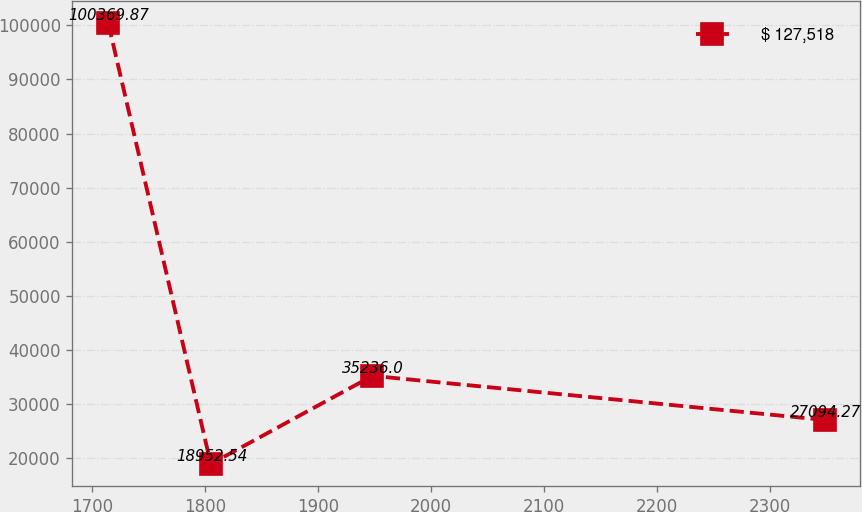Convert chart. <chart><loc_0><loc_0><loc_500><loc_500><line_chart><ecel><fcel>$ 127,518<nl><fcel>1714.1<fcel>100370<nl><fcel>1804.85<fcel>18952.5<nl><fcel>1947.96<fcel>35236<nl><fcel>2348.3<fcel>27094.3<nl></chart> 